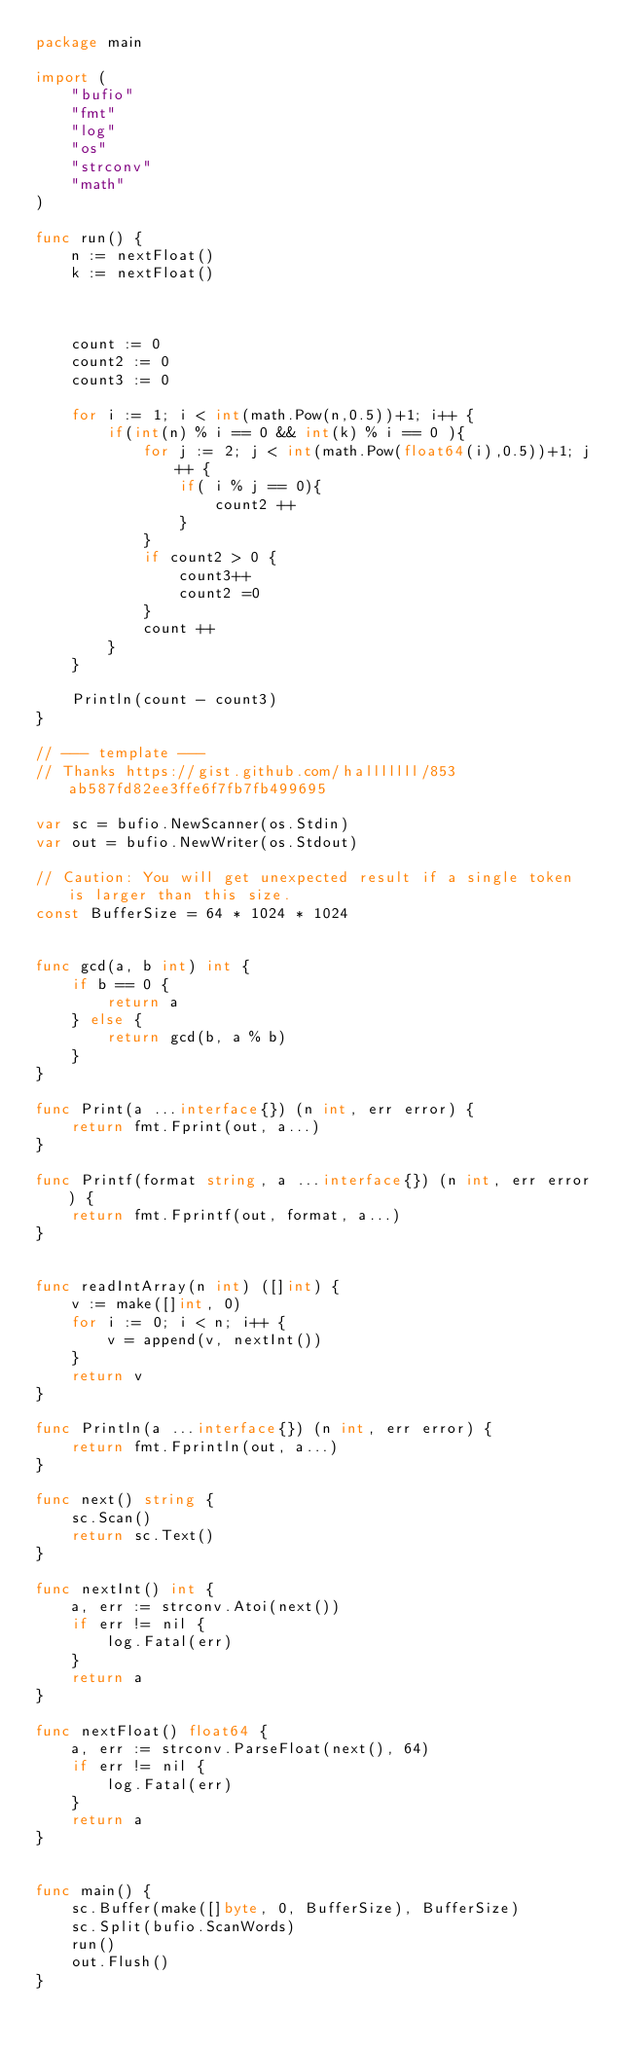<code> <loc_0><loc_0><loc_500><loc_500><_Go_>package main
 
import (
	"bufio"
	"fmt"
	"log"
	"os"
	"strconv"
	"math"
)
 
func run() {
	n := nextFloat()
	k := nextFloat()



	count := 0
	count2 := 0
	count3 := 0

	for i := 1; i < int(math.Pow(n,0.5))+1; i++ {
		if(int(n) % i == 0 && int(k) % i == 0 ){
			for j := 2; j < int(math.Pow(float64(i),0.5))+1; j++ {
				if( i % j == 0){
					count2 ++
				}
			}
			if count2 > 0 {
				count3++
				count2 =0
			}
			count ++
		}
	}

	Println(count - count3)	
}

// --- template ---
// Thanks https://gist.github.com/halllllll/853ab587fd82ee3ffe6f7fb7fb499695
 
var sc = bufio.NewScanner(os.Stdin)
var out = bufio.NewWriter(os.Stdout)
 
// Caution: You will get unexpected result if a single token is larger than this size.
const BufferSize = 64 * 1024 * 1024
 

func gcd(a, b int) int {
    if b == 0 {
        return a
    } else {
        return gcd(b, a % b)
    }
}

func Print(a ...interface{}) (n int, err error) {
	return fmt.Fprint(out, a...)
}
 
func Printf(format string, a ...interface{}) (n int, err error) {
	return fmt.Fprintf(out, format, a...)
}
 

func readIntArray(n int) ([]int) {
	v := make([]int, 0)
	for i := 0; i < n; i++ {
		v = append(v, nextInt())
	}
	return v
}
 
func Println(a ...interface{}) (n int, err error) {
	return fmt.Fprintln(out, a...)
}
 
func next() string {
	sc.Scan()
	return sc.Text()
}
 
func nextInt() int {
	a, err := strconv.Atoi(next())
	if err != nil {
		log.Fatal(err)
	}
	return a
}
 
func nextFloat() float64 {
	a, err := strconv.ParseFloat(next(), 64)
	if err != nil {
		log.Fatal(err)
	}
	return a
}

 
func main() {
	sc.Buffer(make([]byte, 0, BufferSize), BufferSize)
	sc.Split(bufio.ScanWords)
	run()
	out.Flush()
}
</code> 